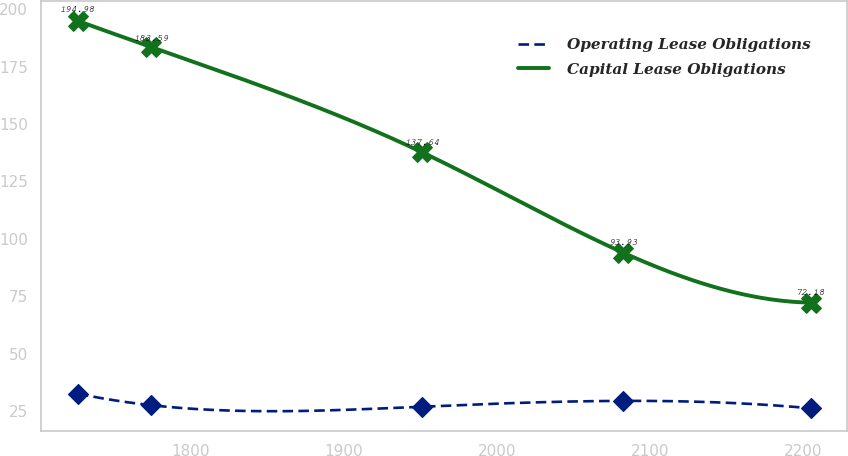Convert chart. <chart><loc_0><loc_0><loc_500><loc_500><line_chart><ecel><fcel>Operating Lease Obligations<fcel>Capital Lease Obligations<nl><fcel>1726.69<fcel>32.51<fcel>194.98<nl><fcel>1774.51<fcel>27.48<fcel>183.59<nl><fcel>1951.52<fcel>26.84<fcel>137.64<nl><fcel>2082.57<fcel>29.36<fcel>93.93<nl><fcel>2204.88<fcel>26.13<fcel>72.18<nl></chart> 